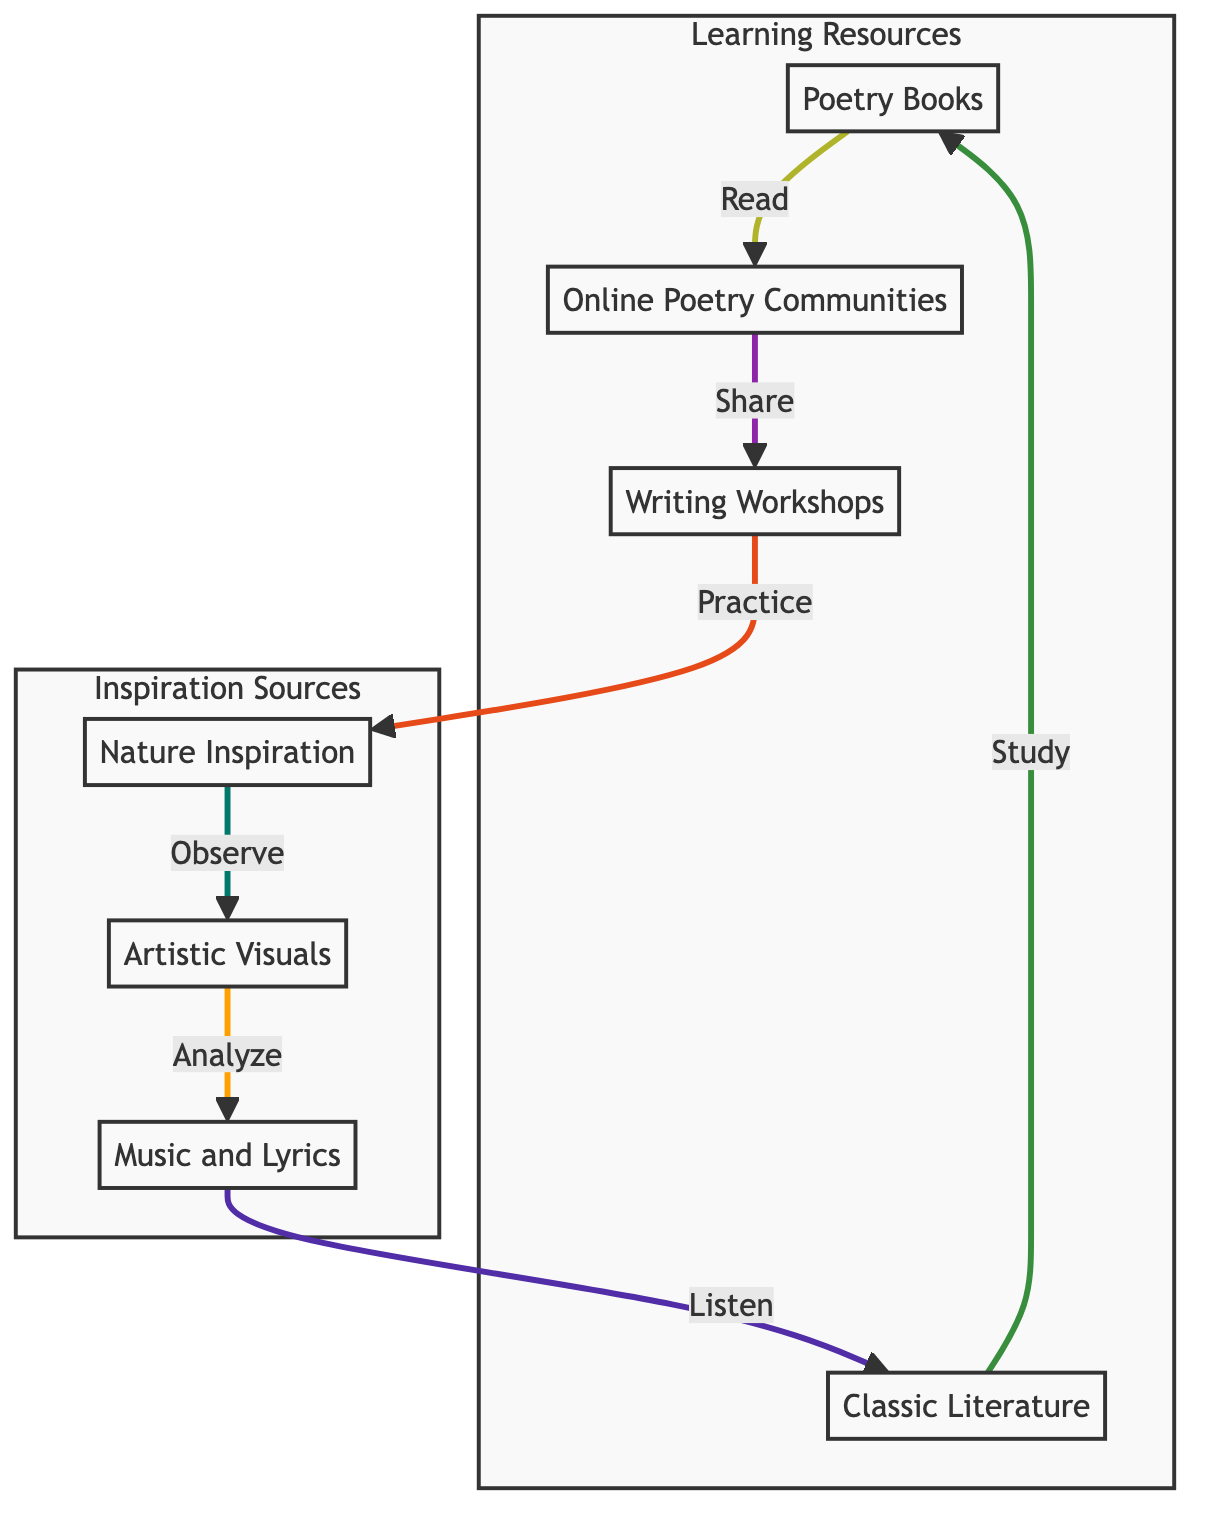How many nodes are in the diagram? The diagram contains a total of seven nodes, which include Poetry Books, Online Poetry Communities, Writing Workshops, Nature Inspiration, Artistic Visuals, Music and Lyrics, and Classic Literature.
Answer: 7 What is the first node in the flow of the diagram? The first node in the flow starts with Poetry Books, which is represented at the top of the diagram.
Answer: Poetry Books Which two nodes are connected directly by the arrow labeled "Share"? The arrow labeled "Share" connects Online Poetry Communities and Writing Workshops, indicating the flow between these two nodes.
Answer: Online Poetry Communities and Writing Workshops What is the last node in the flow of the diagram? The last node in the sequence is Classic Literature, which follows Music and Lyrics in the flowchart.
Answer: Classic Literature Which node is associated with "Observe"? The node that is directly linked to "Observe" is Nature Inspiration, indicating that observing is part of developing poetic elements from nature.
Answer: Nature Inspiration How many subgraphs are present in the diagram? There are two subgraphs present in the diagram, which are labeled Inspiration Sources and Learning Resources.
Answer: 2 Which node leads to the "Listen" action? The node that leads to the "Listen" action is Music and Lyrics, showing the relationship where listening is part of obtaining inspiration from music.
Answer: Music and Lyrics What is the connection between Nature Inspiration and Artistic Visuals? Nature Inspiration connects to Artistic Visuals through the node labeled "Analyze," suggesting that analysis of nature can lead to visual inspiration.
Answer: Analyze What are the components of the Inspiration Sources subgraph? The Inspiration Sources subgraph consists of three nodes: Nature Inspiration, Artistic Visuals, and Music and Lyrics.
Answer: Nature Inspiration, Artistic Visuals, Music and Lyrics 